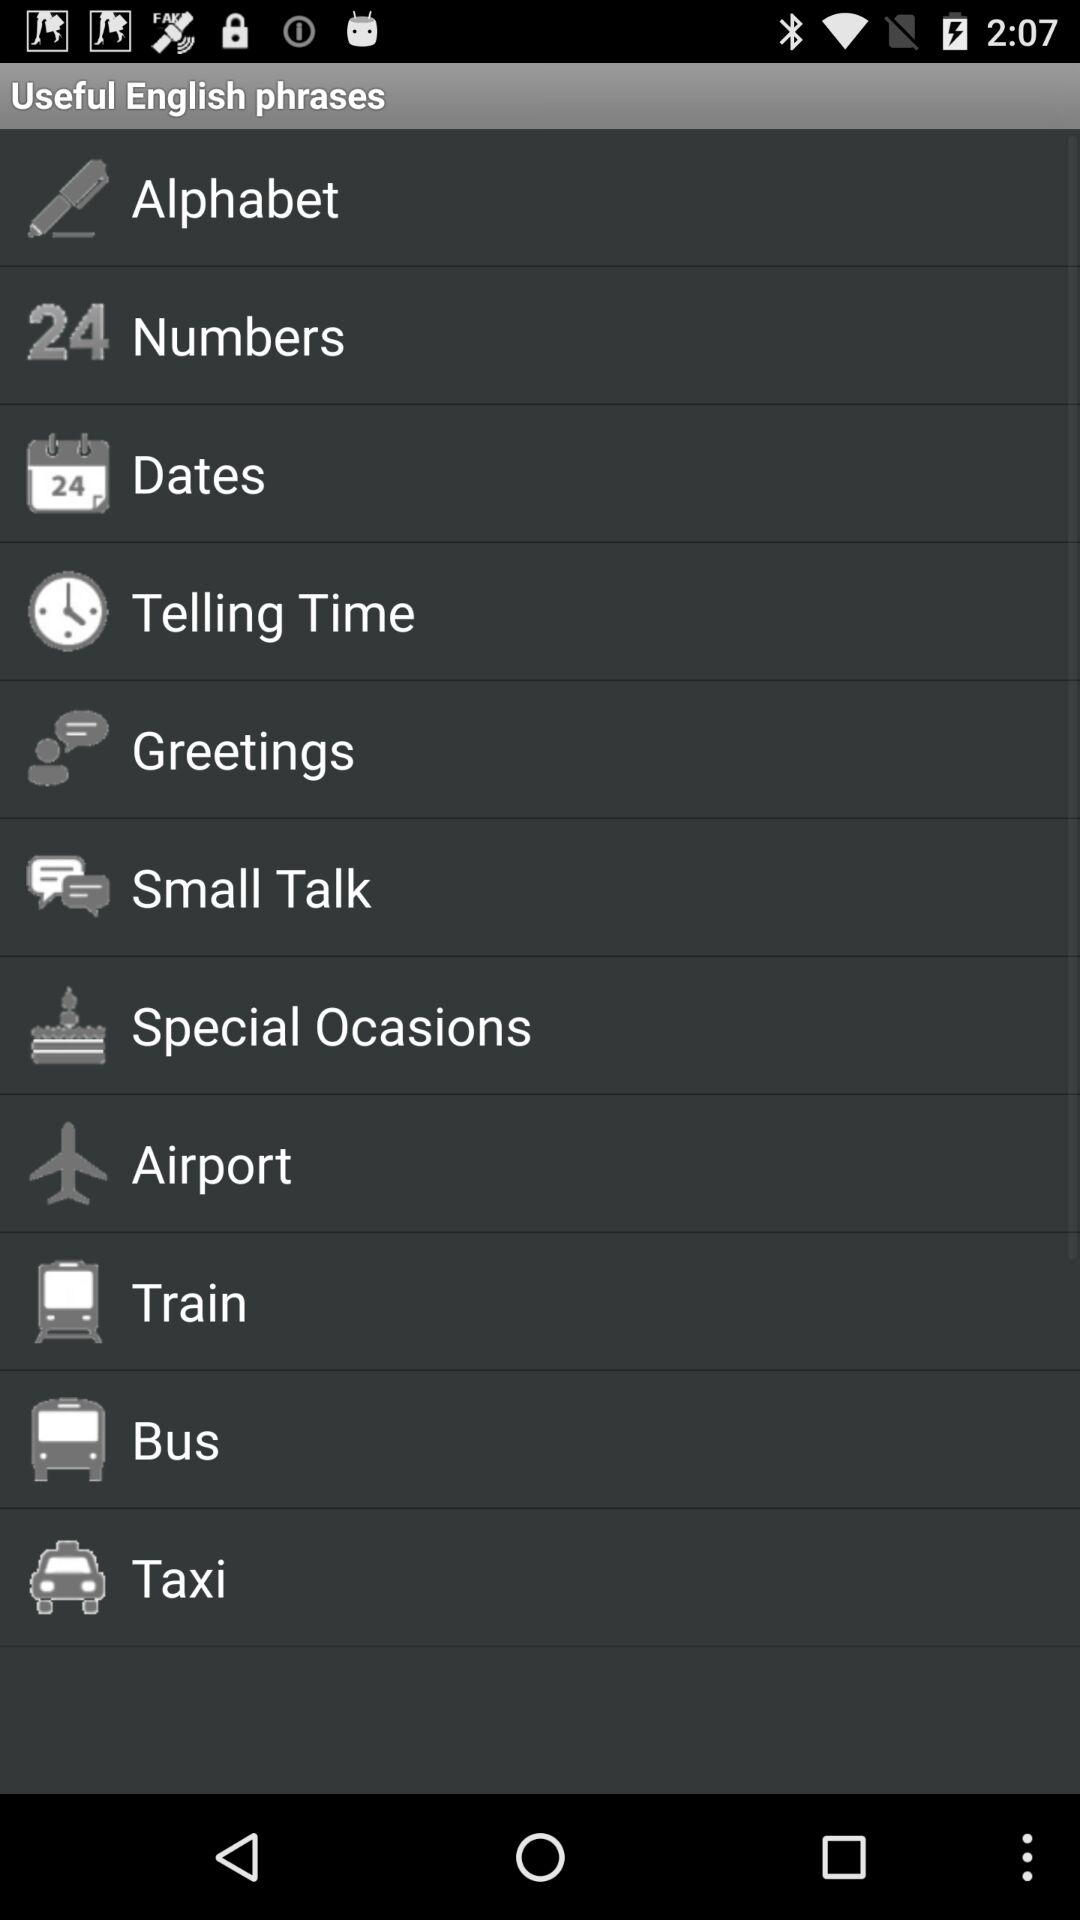How many phrases are about travel?
Answer the question using a single word or phrase. 4 